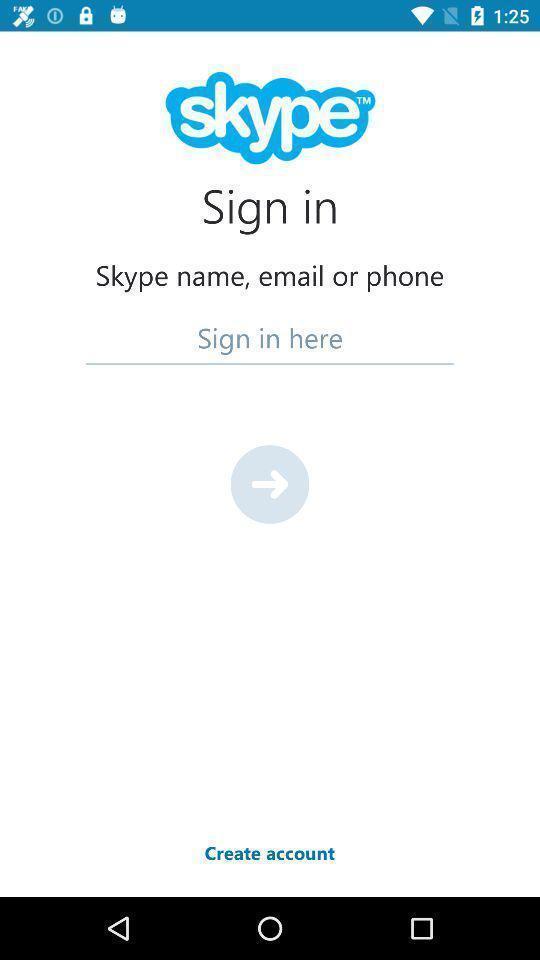Tell me about the visual elements in this screen capture. Sign-in page of a video call app. 